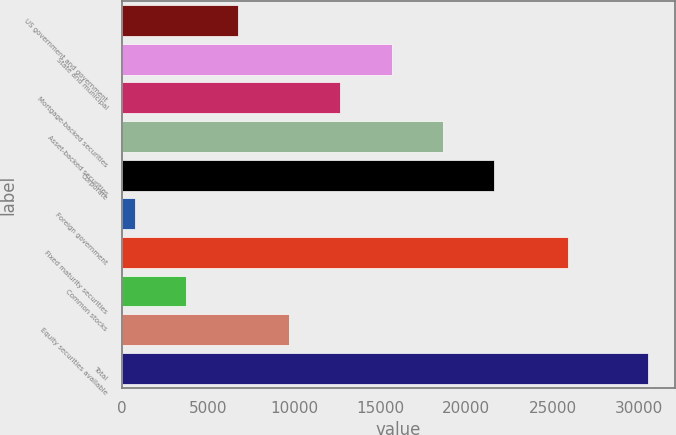Convert chart. <chart><loc_0><loc_0><loc_500><loc_500><bar_chart><fcel>US government and government<fcel>State and municipal<fcel>Mortgage-backed securities<fcel>Asset-backed securities<fcel>Corporate<fcel>Foreign government<fcel>Fixed maturity securities<fcel>Common stocks<fcel>Equity securities available<fcel>Total<nl><fcel>6734.6<fcel>15671<fcel>12692.2<fcel>18649.8<fcel>21628.6<fcel>777<fcel>25902<fcel>3755.8<fcel>9713.4<fcel>30565<nl></chart> 